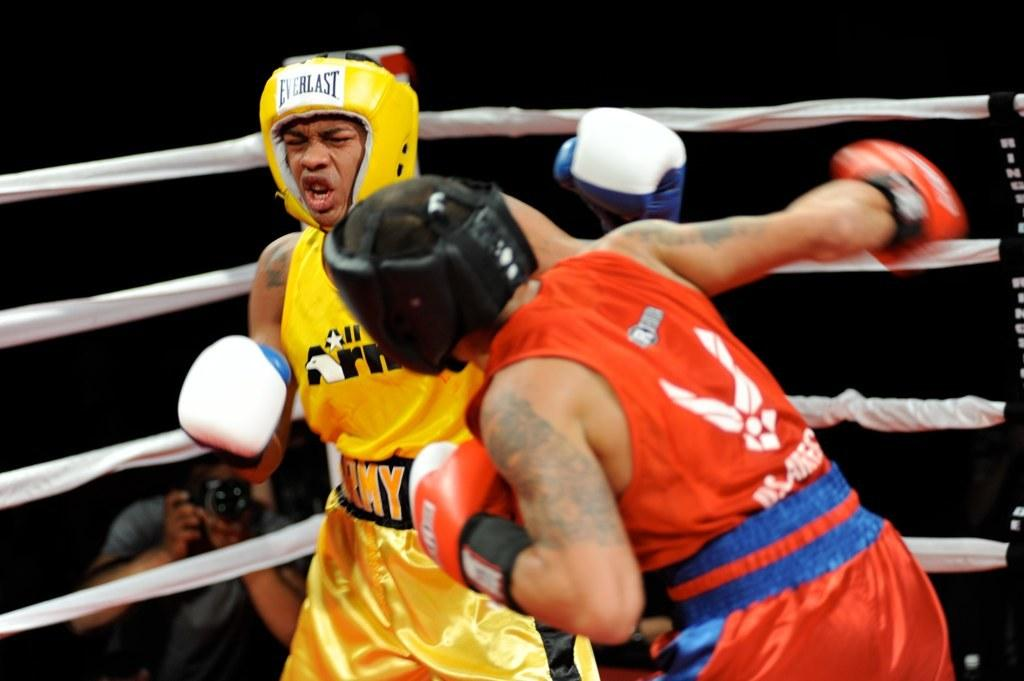How many people are in the image? There are two persons in the image. What colors are the dresses of the two persons? The two persons are wearing red and yellow color dress. What activity are the two persons engaged in? The two persons are playing boxing sport. Can you describe the person in the left corner of the image? There is a person holding a camera in the left corner of the image. What type of locket can be seen around the neck of one of the boxers in the image? There is no locket visible around the neck of either boxer in the image. What musical instrument is being played by one of the boxers during the match? There is no musical instrument being played by either boxer in the image; they are focused on the boxing sport. 